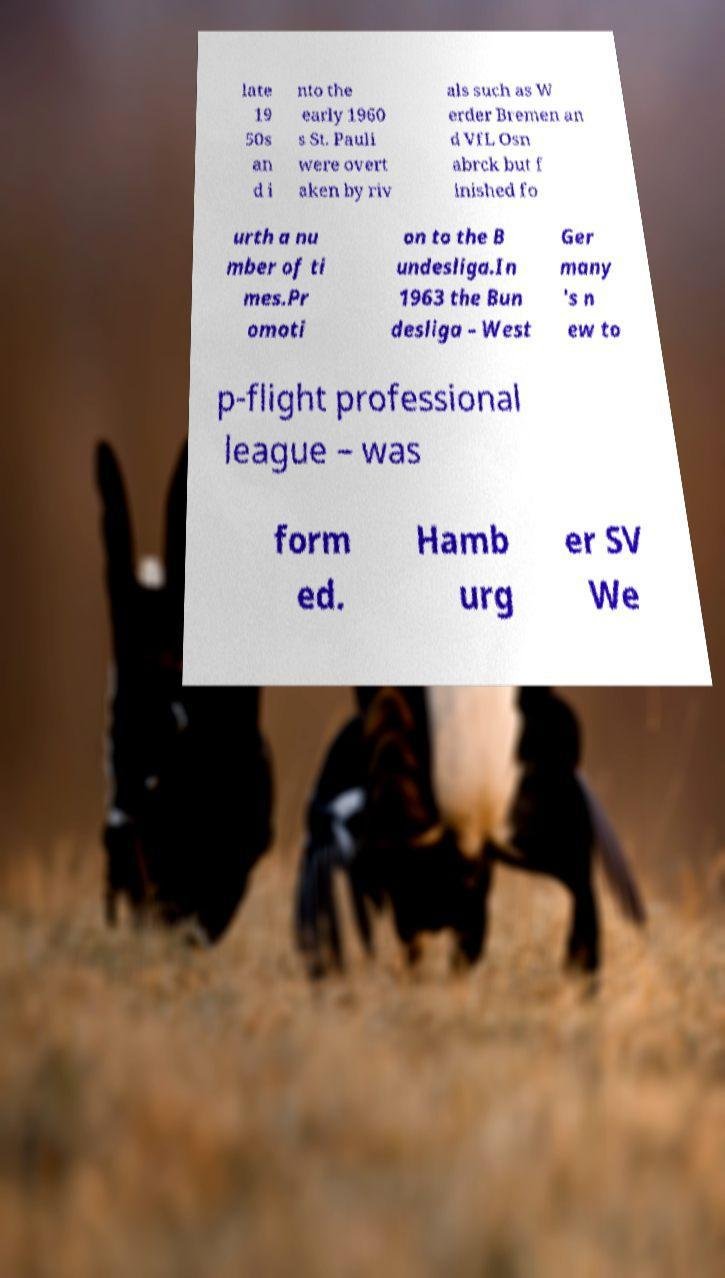Can you accurately transcribe the text from the provided image for me? late 19 50s an d i nto the early 1960 s St. Pauli were overt aken by riv als such as W erder Bremen an d VfL Osn abrck but f inished fo urth a nu mber of ti mes.Pr omoti on to the B undesliga.In 1963 the Bun desliga – West Ger many 's n ew to p-flight professional league – was form ed. Hamb urg er SV We 